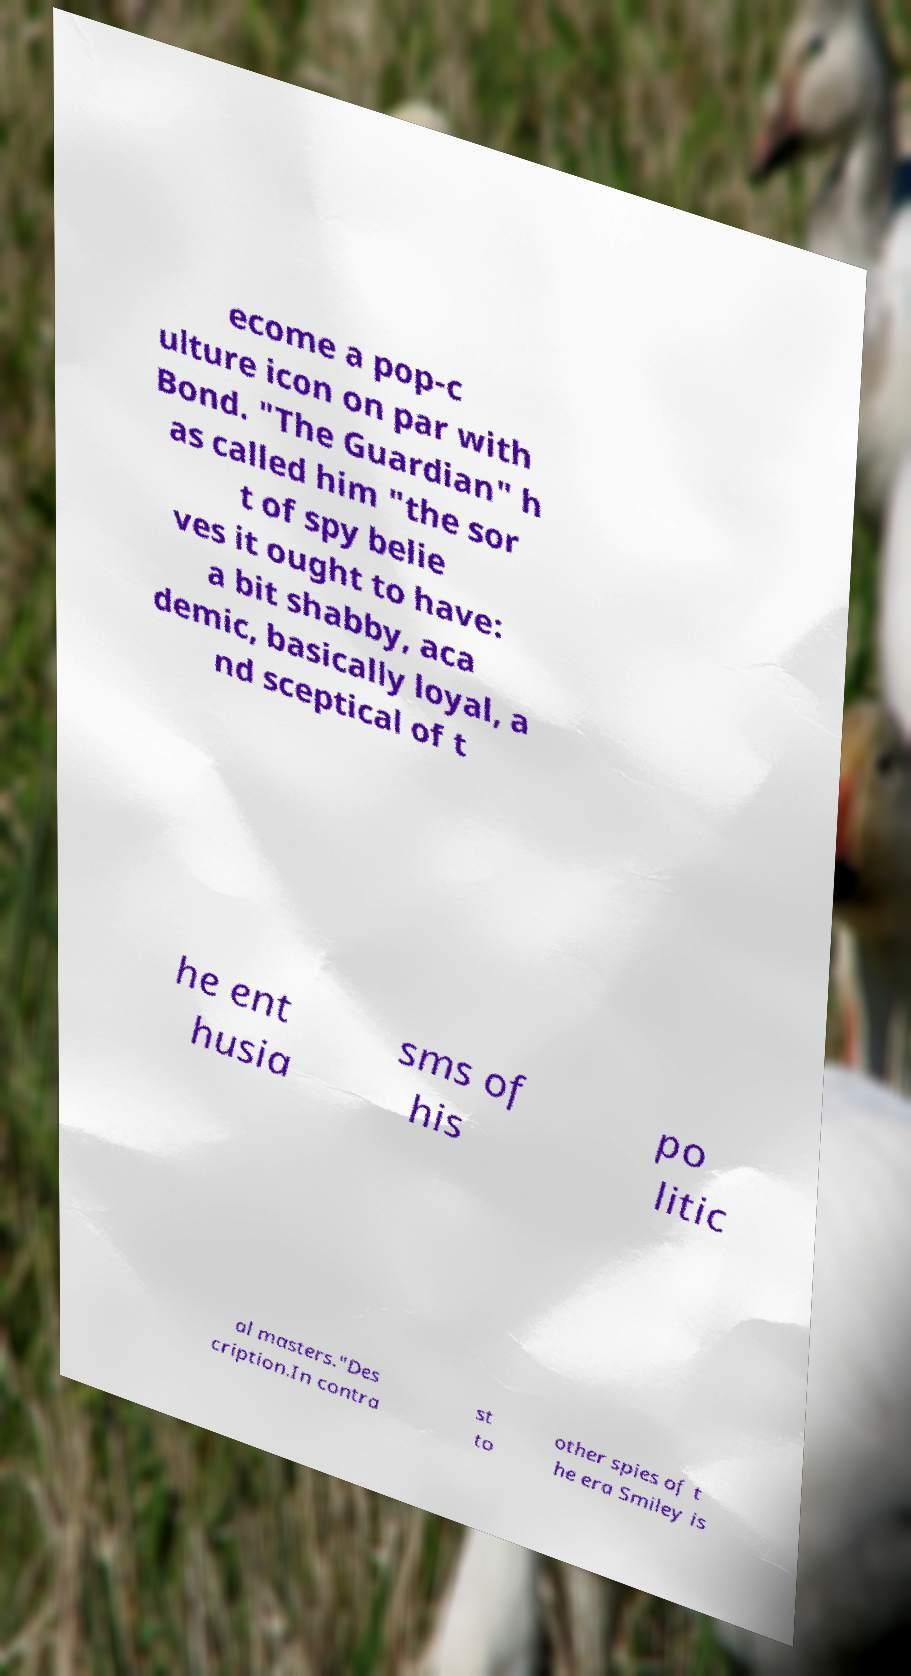I need the written content from this picture converted into text. Can you do that? ecome a pop-c ulture icon on par with Bond. "The Guardian" h as called him "the sor t of spy belie ves it ought to have: a bit shabby, aca demic, basically loyal, a nd sceptical of t he ent husia sms of his po litic al masters."Des cription.In contra st to other spies of t he era Smiley is 